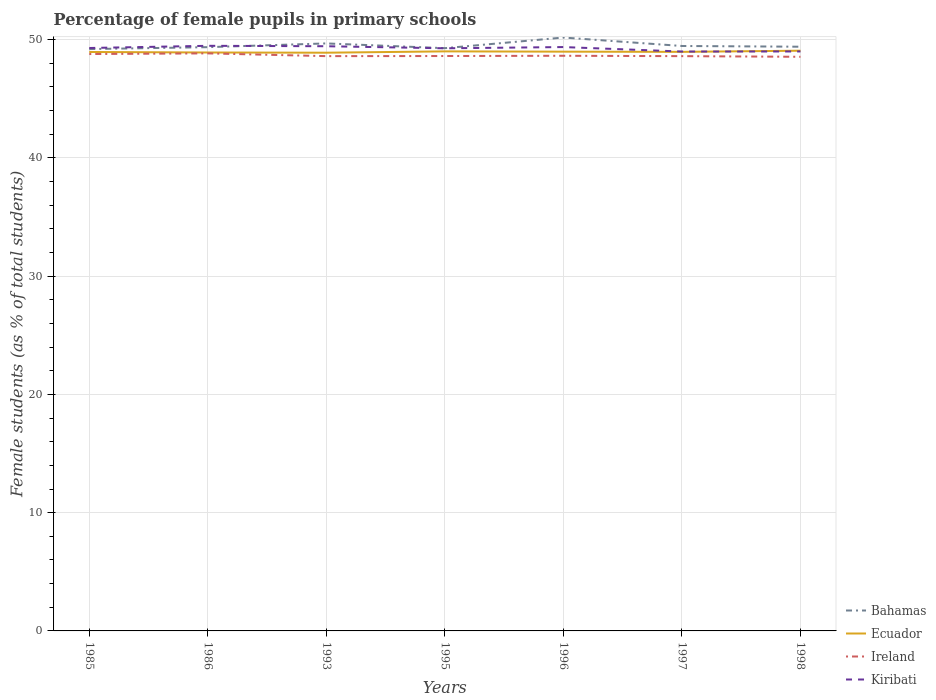Does the line corresponding to Ireland intersect with the line corresponding to Kiribati?
Ensure brevity in your answer.  No. Across all years, what is the maximum percentage of female pupils in primary schools in Ecuador?
Provide a succinct answer. 48.89. What is the total percentage of female pupils in primary schools in Bahamas in the graph?
Your answer should be compact. -0.08. What is the difference between the highest and the second highest percentage of female pupils in primary schools in Ireland?
Your answer should be compact. 0.29. What is the difference between the highest and the lowest percentage of female pupils in primary schools in Kiribati?
Your response must be concise. 5. Is the percentage of female pupils in primary schools in Ecuador strictly greater than the percentage of female pupils in primary schools in Bahamas over the years?
Give a very brief answer. Yes. What is the difference between two consecutive major ticks on the Y-axis?
Make the answer very short. 10. Does the graph contain any zero values?
Make the answer very short. No. Does the graph contain grids?
Keep it short and to the point. Yes. Where does the legend appear in the graph?
Ensure brevity in your answer.  Bottom right. How many legend labels are there?
Your answer should be very brief. 4. What is the title of the graph?
Keep it short and to the point. Percentage of female pupils in primary schools. What is the label or title of the Y-axis?
Keep it short and to the point. Female students (as % of total students). What is the Female students (as % of total students) of Bahamas in 1985?
Keep it short and to the point. 49.2. What is the Female students (as % of total students) of Ecuador in 1985?
Give a very brief answer. 48.96. What is the Female students (as % of total students) of Ireland in 1985?
Offer a very short reply. 48.78. What is the Female students (as % of total students) of Kiribati in 1985?
Offer a very short reply. 49.29. What is the Female students (as % of total students) in Bahamas in 1986?
Your answer should be compact. 49.36. What is the Female students (as % of total students) of Ecuador in 1986?
Ensure brevity in your answer.  48.91. What is the Female students (as % of total students) of Ireland in 1986?
Provide a succinct answer. 48.84. What is the Female students (as % of total students) of Kiribati in 1986?
Offer a terse response. 49.48. What is the Female students (as % of total students) of Bahamas in 1993?
Offer a very short reply. 49.68. What is the Female students (as % of total students) in Ecuador in 1993?
Your answer should be compact. 48.89. What is the Female students (as % of total students) in Ireland in 1993?
Offer a very short reply. 48.6. What is the Female students (as % of total students) in Kiribati in 1993?
Give a very brief answer. 49.44. What is the Female students (as % of total students) of Bahamas in 1995?
Your answer should be very brief. 49.28. What is the Female students (as % of total students) of Ecuador in 1995?
Give a very brief answer. 49.01. What is the Female students (as % of total students) in Ireland in 1995?
Ensure brevity in your answer.  48.61. What is the Female students (as % of total students) of Kiribati in 1995?
Keep it short and to the point. 49.27. What is the Female students (as % of total students) of Bahamas in 1996?
Your answer should be compact. 50.18. What is the Female students (as % of total students) of Ecuador in 1996?
Ensure brevity in your answer.  48.98. What is the Female students (as % of total students) in Ireland in 1996?
Keep it short and to the point. 48.64. What is the Female students (as % of total students) in Kiribati in 1996?
Your answer should be very brief. 49.37. What is the Female students (as % of total students) in Bahamas in 1997?
Make the answer very short. 49.46. What is the Female students (as % of total students) of Ecuador in 1997?
Provide a short and direct response. 48.97. What is the Female students (as % of total students) in Ireland in 1997?
Your response must be concise. 48.6. What is the Female students (as % of total students) in Kiribati in 1997?
Provide a short and direct response. 48.99. What is the Female students (as % of total students) in Bahamas in 1998?
Ensure brevity in your answer.  49.4. What is the Female students (as % of total students) in Ecuador in 1998?
Your answer should be compact. 49.06. What is the Female students (as % of total students) of Ireland in 1998?
Your answer should be very brief. 48.55. What is the Female students (as % of total students) in Kiribati in 1998?
Provide a short and direct response. 49. Across all years, what is the maximum Female students (as % of total students) in Bahamas?
Keep it short and to the point. 50.18. Across all years, what is the maximum Female students (as % of total students) of Ecuador?
Offer a terse response. 49.06. Across all years, what is the maximum Female students (as % of total students) in Ireland?
Keep it short and to the point. 48.84. Across all years, what is the maximum Female students (as % of total students) in Kiribati?
Offer a very short reply. 49.48. Across all years, what is the minimum Female students (as % of total students) of Bahamas?
Ensure brevity in your answer.  49.2. Across all years, what is the minimum Female students (as % of total students) in Ecuador?
Your response must be concise. 48.89. Across all years, what is the minimum Female students (as % of total students) of Ireland?
Offer a very short reply. 48.55. Across all years, what is the minimum Female students (as % of total students) in Kiribati?
Offer a very short reply. 48.99. What is the total Female students (as % of total students) of Bahamas in the graph?
Your answer should be compact. 346.56. What is the total Female students (as % of total students) of Ecuador in the graph?
Offer a very short reply. 342.78. What is the total Female students (as % of total students) in Ireland in the graph?
Make the answer very short. 340.63. What is the total Female students (as % of total students) of Kiribati in the graph?
Your response must be concise. 344.85. What is the difference between the Female students (as % of total students) of Bahamas in 1985 and that in 1986?
Your answer should be compact. -0.16. What is the difference between the Female students (as % of total students) of Ecuador in 1985 and that in 1986?
Your answer should be very brief. 0.04. What is the difference between the Female students (as % of total students) of Ireland in 1985 and that in 1986?
Provide a succinct answer. -0.06. What is the difference between the Female students (as % of total students) in Kiribati in 1985 and that in 1986?
Keep it short and to the point. -0.19. What is the difference between the Female students (as % of total students) of Bahamas in 1985 and that in 1993?
Offer a terse response. -0.48. What is the difference between the Female students (as % of total students) in Ecuador in 1985 and that in 1993?
Your response must be concise. 0.06. What is the difference between the Female students (as % of total students) in Ireland in 1985 and that in 1993?
Offer a terse response. 0.18. What is the difference between the Female students (as % of total students) of Kiribati in 1985 and that in 1993?
Your answer should be compact. -0.15. What is the difference between the Female students (as % of total students) in Bahamas in 1985 and that in 1995?
Your response must be concise. -0.08. What is the difference between the Female students (as % of total students) of Ecuador in 1985 and that in 1995?
Offer a terse response. -0.05. What is the difference between the Female students (as % of total students) in Ireland in 1985 and that in 1995?
Offer a terse response. 0.17. What is the difference between the Female students (as % of total students) of Kiribati in 1985 and that in 1995?
Your answer should be compact. 0.02. What is the difference between the Female students (as % of total students) of Bahamas in 1985 and that in 1996?
Keep it short and to the point. -0.98. What is the difference between the Female students (as % of total students) of Ecuador in 1985 and that in 1996?
Provide a short and direct response. -0.03. What is the difference between the Female students (as % of total students) in Ireland in 1985 and that in 1996?
Give a very brief answer. 0.15. What is the difference between the Female students (as % of total students) of Kiribati in 1985 and that in 1996?
Make the answer very short. -0.08. What is the difference between the Female students (as % of total students) in Bahamas in 1985 and that in 1997?
Your response must be concise. -0.26. What is the difference between the Female students (as % of total students) of Ecuador in 1985 and that in 1997?
Provide a succinct answer. -0.01. What is the difference between the Female students (as % of total students) of Ireland in 1985 and that in 1997?
Offer a very short reply. 0.18. What is the difference between the Female students (as % of total students) of Kiribati in 1985 and that in 1997?
Keep it short and to the point. 0.3. What is the difference between the Female students (as % of total students) of Bahamas in 1985 and that in 1998?
Offer a very short reply. -0.2. What is the difference between the Female students (as % of total students) in Ecuador in 1985 and that in 1998?
Your answer should be very brief. -0.11. What is the difference between the Female students (as % of total students) in Ireland in 1985 and that in 1998?
Your response must be concise. 0.23. What is the difference between the Female students (as % of total students) in Kiribati in 1985 and that in 1998?
Provide a succinct answer. 0.29. What is the difference between the Female students (as % of total students) of Bahamas in 1986 and that in 1993?
Your response must be concise. -0.32. What is the difference between the Female students (as % of total students) of Ecuador in 1986 and that in 1993?
Your response must be concise. 0.02. What is the difference between the Female students (as % of total students) in Ireland in 1986 and that in 1993?
Make the answer very short. 0.23. What is the difference between the Female students (as % of total students) in Kiribati in 1986 and that in 1993?
Offer a terse response. 0.04. What is the difference between the Female students (as % of total students) of Bahamas in 1986 and that in 1995?
Make the answer very short. 0.09. What is the difference between the Female students (as % of total students) of Ecuador in 1986 and that in 1995?
Your answer should be compact. -0.1. What is the difference between the Female students (as % of total students) in Ireland in 1986 and that in 1995?
Provide a succinct answer. 0.22. What is the difference between the Female students (as % of total students) in Kiribati in 1986 and that in 1995?
Give a very brief answer. 0.21. What is the difference between the Female students (as % of total students) of Bahamas in 1986 and that in 1996?
Your answer should be compact. -0.81. What is the difference between the Female students (as % of total students) in Ecuador in 1986 and that in 1996?
Your answer should be compact. -0.07. What is the difference between the Female students (as % of total students) of Ireland in 1986 and that in 1996?
Provide a succinct answer. 0.2. What is the difference between the Female students (as % of total students) of Kiribati in 1986 and that in 1996?
Offer a very short reply. 0.11. What is the difference between the Female students (as % of total students) in Bahamas in 1986 and that in 1997?
Offer a terse response. -0.1. What is the difference between the Female students (as % of total students) of Ecuador in 1986 and that in 1997?
Keep it short and to the point. -0.05. What is the difference between the Female students (as % of total students) of Ireland in 1986 and that in 1997?
Offer a very short reply. 0.23. What is the difference between the Female students (as % of total students) of Kiribati in 1986 and that in 1997?
Provide a succinct answer. 0.48. What is the difference between the Female students (as % of total students) in Bahamas in 1986 and that in 1998?
Make the answer very short. -0.04. What is the difference between the Female students (as % of total students) in Ecuador in 1986 and that in 1998?
Your response must be concise. -0.15. What is the difference between the Female students (as % of total students) in Ireland in 1986 and that in 1998?
Provide a succinct answer. 0.29. What is the difference between the Female students (as % of total students) in Kiribati in 1986 and that in 1998?
Provide a short and direct response. 0.48. What is the difference between the Female students (as % of total students) in Bahamas in 1993 and that in 1995?
Make the answer very short. 0.4. What is the difference between the Female students (as % of total students) of Ecuador in 1993 and that in 1995?
Give a very brief answer. -0.11. What is the difference between the Female students (as % of total students) of Ireland in 1993 and that in 1995?
Your response must be concise. -0.01. What is the difference between the Female students (as % of total students) in Kiribati in 1993 and that in 1995?
Offer a very short reply. 0.17. What is the difference between the Female students (as % of total students) in Bahamas in 1993 and that in 1996?
Provide a succinct answer. -0.5. What is the difference between the Female students (as % of total students) in Ecuador in 1993 and that in 1996?
Provide a short and direct response. -0.09. What is the difference between the Female students (as % of total students) of Ireland in 1993 and that in 1996?
Your answer should be compact. -0.03. What is the difference between the Female students (as % of total students) of Kiribati in 1993 and that in 1996?
Offer a terse response. 0.07. What is the difference between the Female students (as % of total students) of Bahamas in 1993 and that in 1997?
Keep it short and to the point. 0.22. What is the difference between the Female students (as % of total students) of Ecuador in 1993 and that in 1997?
Provide a succinct answer. -0.07. What is the difference between the Female students (as % of total students) in Kiribati in 1993 and that in 1997?
Keep it short and to the point. 0.45. What is the difference between the Female students (as % of total students) in Bahamas in 1993 and that in 1998?
Keep it short and to the point. 0.28. What is the difference between the Female students (as % of total students) of Ecuador in 1993 and that in 1998?
Offer a terse response. -0.17. What is the difference between the Female students (as % of total students) of Ireland in 1993 and that in 1998?
Keep it short and to the point. 0.06. What is the difference between the Female students (as % of total students) of Kiribati in 1993 and that in 1998?
Give a very brief answer. 0.44. What is the difference between the Female students (as % of total students) in Bahamas in 1995 and that in 1996?
Give a very brief answer. -0.9. What is the difference between the Female students (as % of total students) in Ecuador in 1995 and that in 1996?
Provide a short and direct response. 0.02. What is the difference between the Female students (as % of total students) in Ireland in 1995 and that in 1996?
Your response must be concise. -0.02. What is the difference between the Female students (as % of total students) in Kiribati in 1995 and that in 1996?
Your answer should be very brief. -0.1. What is the difference between the Female students (as % of total students) in Bahamas in 1995 and that in 1997?
Offer a terse response. -0.18. What is the difference between the Female students (as % of total students) in Ecuador in 1995 and that in 1997?
Give a very brief answer. 0.04. What is the difference between the Female students (as % of total students) in Ireland in 1995 and that in 1997?
Offer a very short reply. 0.01. What is the difference between the Female students (as % of total students) of Kiribati in 1995 and that in 1997?
Keep it short and to the point. 0.27. What is the difference between the Female students (as % of total students) in Bahamas in 1995 and that in 1998?
Provide a succinct answer. -0.12. What is the difference between the Female students (as % of total students) of Ecuador in 1995 and that in 1998?
Make the answer very short. -0.06. What is the difference between the Female students (as % of total students) of Ireland in 1995 and that in 1998?
Give a very brief answer. 0.07. What is the difference between the Female students (as % of total students) of Kiribati in 1995 and that in 1998?
Keep it short and to the point. 0.27. What is the difference between the Female students (as % of total students) of Bahamas in 1996 and that in 1997?
Keep it short and to the point. 0.71. What is the difference between the Female students (as % of total students) in Ecuador in 1996 and that in 1997?
Keep it short and to the point. 0.02. What is the difference between the Female students (as % of total students) of Ireland in 1996 and that in 1997?
Keep it short and to the point. 0.03. What is the difference between the Female students (as % of total students) in Kiribati in 1996 and that in 1997?
Your answer should be very brief. 0.38. What is the difference between the Female students (as % of total students) of Bahamas in 1996 and that in 1998?
Your answer should be compact. 0.78. What is the difference between the Female students (as % of total students) of Ecuador in 1996 and that in 1998?
Offer a very short reply. -0.08. What is the difference between the Female students (as % of total students) of Ireland in 1996 and that in 1998?
Offer a terse response. 0.09. What is the difference between the Female students (as % of total students) in Kiribati in 1996 and that in 1998?
Provide a short and direct response. 0.37. What is the difference between the Female students (as % of total students) in Bahamas in 1997 and that in 1998?
Make the answer very short. 0.06. What is the difference between the Female students (as % of total students) of Ecuador in 1997 and that in 1998?
Give a very brief answer. -0.1. What is the difference between the Female students (as % of total students) in Ireland in 1997 and that in 1998?
Keep it short and to the point. 0.05. What is the difference between the Female students (as % of total students) of Kiribati in 1997 and that in 1998?
Keep it short and to the point. -0.01. What is the difference between the Female students (as % of total students) in Bahamas in 1985 and the Female students (as % of total students) in Ecuador in 1986?
Keep it short and to the point. 0.29. What is the difference between the Female students (as % of total students) in Bahamas in 1985 and the Female students (as % of total students) in Ireland in 1986?
Ensure brevity in your answer.  0.36. What is the difference between the Female students (as % of total students) in Bahamas in 1985 and the Female students (as % of total students) in Kiribati in 1986?
Your answer should be compact. -0.28. What is the difference between the Female students (as % of total students) of Ecuador in 1985 and the Female students (as % of total students) of Ireland in 1986?
Your response must be concise. 0.12. What is the difference between the Female students (as % of total students) in Ecuador in 1985 and the Female students (as % of total students) in Kiribati in 1986?
Keep it short and to the point. -0.52. What is the difference between the Female students (as % of total students) in Ireland in 1985 and the Female students (as % of total students) in Kiribati in 1986?
Your answer should be compact. -0.7. What is the difference between the Female students (as % of total students) of Bahamas in 1985 and the Female students (as % of total students) of Ecuador in 1993?
Your response must be concise. 0.31. What is the difference between the Female students (as % of total students) in Bahamas in 1985 and the Female students (as % of total students) in Ireland in 1993?
Your answer should be compact. 0.6. What is the difference between the Female students (as % of total students) of Bahamas in 1985 and the Female students (as % of total students) of Kiribati in 1993?
Make the answer very short. -0.24. What is the difference between the Female students (as % of total students) of Ecuador in 1985 and the Female students (as % of total students) of Ireland in 1993?
Give a very brief answer. 0.35. What is the difference between the Female students (as % of total students) of Ecuador in 1985 and the Female students (as % of total students) of Kiribati in 1993?
Keep it short and to the point. -0.49. What is the difference between the Female students (as % of total students) of Ireland in 1985 and the Female students (as % of total students) of Kiribati in 1993?
Keep it short and to the point. -0.66. What is the difference between the Female students (as % of total students) of Bahamas in 1985 and the Female students (as % of total students) of Ecuador in 1995?
Offer a very short reply. 0.19. What is the difference between the Female students (as % of total students) in Bahamas in 1985 and the Female students (as % of total students) in Ireland in 1995?
Offer a very short reply. 0.59. What is the difference between the Female students (as % of total students) of Bahamas in 1985 and the Female students (as % of total students) of Kiribati in 1995?
Your answer should be compact. -0.07. What is the difference between the Female students (as % of total students) in Ecuador in 1985 and the Female students (as % of total students) in Ireland in 1995?
Keep it short and to the point. 0.34. What is the difference between the Female students (as % of total students) of Ecuador in 1985 and the Female students (as % of total students) of Kiribati in 1995?
Ensure brevity in your answer.  -0.31. What is the difference between the Female students (as % of total students) in Ireland in 1985 and the Female students (as % of total students) in Kiribati in 1995?
Offer a terse response. -0.49. What is the difference between the Female students (as % of total students) in Bahamas in 1985 and the Female students (as % of total students) in Ecuador in 1996?
Your answer should be very brief. 0.22. What is the difference between the Female students (as % of total students) of Bahamas in 1985 and the Female students (as % of total students) of Ireland in 1996?
Offer a terse response. 0.57. What is the difference between the Female students (as % of total students) of Bahamas in 1985 and the Female students (as % of total students) of Kiribati in 1996?
Make the answer very short. -0.17. What is the difference between the Female students (as % of total students) of Ecuador in 1985 and the Female students (as % of total students) of Ireland in 1996?
Ensure brevity in your answer.  0.32. What is the difference between the Female students (as % of total students) in Ecuador in 1985 and the Female students (as % of total students) in Kiribati in 1996?
Make the answer very short. -0.42. What is the difference between the Female students (as % of total students) of Ireland in 1985 and the Female students (as % of total students) of Kiribati in 1996?
Give a very brief answer. -0.59. What is the difference between the Female students (as % of total students) of Bahamas in 1985 and the Female students (as % of total students) of Ecuador in 1997?
Offer a very short reply. 0.23. What is the difference between the Female students (as % of total students) of Bahamas in 1985 and the Female students (as % of total students) of Ireland in 1997?
Your response must be concise. 0.6. What is the difference between the Female students (as % of total students) of Bahamas in 1985 and the Female students (as % of total students) of Kiribati in 1997?
Keep it short and to the point. 0.21. What is the difference between the Female students (as % of total students) of Ecuador in 1985 and the Female students (as % of total students) of Ireland in 1997?
Your response must be concise. 0.35. What is the difference between the Female students (as % of total students) of Ecuador in 1985 and the Female students (as % of total students) of Kiribati in 1997?
Offer a terse response. -0.04. What is the difference between the Female students (as % of total students) in Ireland in 1985 and the Female students (as % of total students) in Kiribati in 1997?
Give a very brief answer. -0.21. What is the difference between the Female students (as % of total students) in Bahamas in 1985 and the Female students (as % of total students) in Ecuador in 1998?
Make the answer very short. 0.14. What is the difference between the Female students (as % of total students) of Bahamas in 1985 and the Female students (as % of total students) of Ireland in 1998?
Ensure brevity in your answer.  0.65. What is the difference between the Female students (as % of total students) in Bahamas in 1985 and the Female students (as % of total students) in Kiribati in 1998?
Keep it short and to the point. 0.2. What is the difference between the Female students (as % of total students) in Ecuador in 1985 and the Female students (as % of total students) in Ireland in 1998?
Your answer should be compact. 0.41. What is the difference between the Female students (as % of total students) in Ecuador in 1985 and the Female students (as % of total students) in Kiribati in 1998?
Your answer should be very brief. -0.04. What is the difference between the Female students (as % of total students) in Ireland in 1985 and the Female students (as % of total students) in Kiribati in 1998?
Offer a very short reply. -0.22. What is the difference between the Female students (as % of total students) in Bahamas in 1986 and the Female students (as % of total students) in Ecuador in 1993?
Give a very brief answer. 0.47. What is the difference between the Female students (as % of total students) of Bahamas in 1986 and the Female students (as % of total students) of Ireland in 1993?
Offer a very short reply. 0.76. What is the difference between the Female students (as % of total students) of Bahamas in 1986 and the Female students (as % of total students) of Kiribati in 1993?
Make the answer very short. -0.08. What is the difference between the Female students (as % of total students) in Ecuador in 1986 and the Female students (as % of total students) in Ireland in 1993?
Offer a terse response. 0.31. What is the difference between the Female students (as % of total students) of Ecuador in 1986 and the Female students (as % of total students) of Kiribati in 1993?
Provide a short and direct response. -0.53. What is the difference between the Female students (as % of total students) of Ireland in 1986 and the Female students (as % of total students) of Kiribati in 1993?
Keep it short and to the point. -0.6. What is the difference between the Female students (as % of total students) in Bahamas in 1986 and the Female students (as % of total students) in Ecuador in 1995?
Provide a short and direct response. 0.36. What is the difference between the Female students (as % of total students) of Bahamas in 1986 and the Female students (as % of total students) of Ireland in 1995?
Your answer should be compact. 0.75. What is the difference between the Female students (as % of total students) of Bahamas in 1986 and the Female students (as % of total students) of Kiribati in 1995?
Your response must be concise. 0.1. What is the difference between the Female students (as % of total students) in Ecuador in 1986 and the Female students (as % of total students) in Ireland in 1995?
Offer a terse response. 0.3. What is the difference between the Female students (as % of total students) of Ecuador in 1986 and the Female students (as % of total students) of Kiribati in 1995?
Your answer should be very brief. -0.36. What is the difference between the Female students (as % of total students) in Ireland in 1986 and the Female students (as % of total students) in Kiribati in 1995?
Ensure brevity in your answer.  -0.43. What is the difference between the Female students (as % of total students) of Bahamas in 1986 and the Female students (as % of total students) of Ecuador in 1996?
Keep it short and to the point. 0.38. What is the difference between the Female students (as % of total students) of Bahamas in 1986 and the Female students (as % of total students) of Ireland in 1996?
Your answer should be compact. 0.73. What is the difference between the Female students (as % of total students) of Bahamas in 1986 and the Female students (as % of total students) of Kiribati in 1996?
Give a very brief answer. -0.01. What is the difference between the Female students (as % of total students) in Ecuador in 1986 and the Female students (as % of total students) in Ireland in 1996?
Keep it short and to the point. 0.28. What is the difference between the Female students (as % of total students) of Ecuador in 1986 and the Female students (as % of total students) of Kiribati in 1996?
Provide a succinct answer. -0.46. What is the difference between the Female students (as % of total students) of Ireland in 1986 and the Female students (as % of total students) of Kiribati in 1996?
Keep it short and to the point. -0.53. What is the difference between the Female students (as % of total students) of Bahamas in 1986 and the Female students (as % of total students) of Ecuador in 1997?
Your answer should be very brief. 0.4. What is the difference between the Female students (as % of total students) in Bahamas in 1986 and the Female students (as % of total students) in Ireland in 1997?
Your answer should be very brief. 0.76. What is the difference between the Female students (as % of total students) in Bahamas in 1986 and the Female students (as % of total students) in Kiribati in 1997?
Ensure brevity in your answer.  0.37. What is the difference between the Female students (as % of total students) in Ecuador in 1986 and the Female students (as % of total students) in Ireland in 1997?
Offer a very short reply. 0.31. What is the difference between the Female students (as % of total students) in Ecuador in 1986 and the Female students (as % of total students) in Kiribati in 1997?
Ensure brevity in your answer.  -0.08. What is the difference between the Female students (as % of total students) of Ireland in 1986 and the Female students (as % of total students) of Kiribati in 1997?
Give a very brief answer. -0.16. What is the difference between the Female students (as % of total students) in Bahamas in 1986 and the Female students (as % of total students) in Ireland in 1998?
Your answer should be very brief. 0.81. What is the difference between the Female students (as % of total students) of Bahamas in 1986 and the Female students (as % of total students) of Kiribati in 1998?
Provide a short and direct response. 0.36. What is the difference between the Female students (as % of total students) of Ecuador in 1986 and the Female students (as % of total students) of Ireland in 1998?
Ensure brevity in your answer.  0.36. What is the difference between the Female students (as % of total students) of Ecuador in 1986 and the Female students (as % of total students) of Kiribati in 1998?
Your response must be concise. -0.09. What is the difference between the Female students (as % of total students) in Ireland in 1986 and the Female students (as % of total students) in Kiribati in 1998?
Offer a very short reply. -0.16. What is the difference between the Female students (as % of total students) in Bahamas in 1993 and the Female students (as % of total students) in Ecuador in 1995?
Make the answer very short. 0.67. What is the difference between the Female students (as % of total students) of Bahamas in 1993 and the Female students (as % of total students) of Ireland in 1995?
Your answer should be compact. 1.07. What is the difference between the Female students (as % of total students) in Bahamas in 1993 and the Female students (as % of total students) in Kiribati in 1995?
Ensure brevity in your answer.  0.41. What is the difference between the Female students (as % of total students) of Ecuador in 1993 and the Female students (as % of total students) of Ireland in 1995?
Offer a terse response. 0.28. What is the difference between the Female students (as % of total students) of Ecuador in 1993 and the Female students (as % of total students) of Kiribati in 1995?
Make the answer very short. -0.37. What is the difference between the Female students (as % of total students) in Ireland in 1993 and the Female students (as % of total students) in Kiribati in 1995?
Offer a terse response. -0.66. What is the difference between the Female students (as % of total students) of Bahamas in 1993 and the Female students (as % of total students) of Ecuador in 1996?
Your answer should be compact. 0.7. What is the difference between the Female students (as % of total students) in Bahamas in 1993 and the Female students (as % of total students) in Ireland in 1996?
Keep it short and to the point. 1.04. What is the difference between the Female students (as % of total students) in Bahamas in 1993 and the Female students (as % of total students) in Kiribati in 1996?
Provide a succinct answer. 0.31. What is the difference between the Female students (as % of total students) in Ecuador in 1993 and the Female students (as % of total students) in Ireland in 1996?
Keep it short and to the point. 0.26. What is the difference between the Female students (as % of total students) in Ecuador in 1993 and the Female students (as % of total students) in Kiribati in 1996?
Provide a succinct answer. -0.48. What is the difference between the Female students (as % of total students) in Ireland in 1993 and the Female students (as % of total students) in Kiribati in 1996?
Your answer should be compact. -0.77. What is the difference between the Female students (as % of total students) of Bahamas in 1993 and the Female students (as % of total students) of Ecuador in 1997?
Your answer should be compact. 0.71. What is the difference between the Female students (as % of total students) in Bahamas in 1993 and the Female students (as % of total students) in Ireland in 1997?
Offer a terse response. 1.08. What is the difference between the Female students (as % of total students) of Bahamas in 1993 and the Female students (as % of total students) of Kiribati in 1997?
Make the answer very short. 0.69. What is the difference between the Female students (as % of total students) of Ecuador in 1993 and the Female students (as % of total students) of Ireland in 1997?
Provide a succinct answer. 0.29. What is the difference between the Female students (as % of total students) of Ecuador in 1993 and the Female students (as % of total students) of Kiribati in 1997?
Provide a succinct answer. -0.1. What is the difference between the Female students (as % of total students) of Ireland in 1993 and the Female students (as % of total students) of Kiribati in 1997?
Your answer should be compact. -0.39. What is the difference between the Female students (as % of total students) of Bahamas in 1993 and the Female students (as % of total students) of Ecuador in 1998?
Make the answer very short. 0.62. What is the difference between the Female students (as % of total students) of Bahamas in 1993 and the Female students (as % of total students) of Ireland in 1998?
Provide a short and direct response. 1.13. What is the difference between the Female students (as % of total students) in Bahamas in 1993 and the Female students (as % of total students) in Kiribati in 1998?
Make the answer very short. 0.68. What is the difference between the Female students (as % of total students) in Ecuador in 1993 and the Female students (as % of total students) in Ireland in 1998?
Your response must be concise. 0.34. What is the difference between the Female students (as % of total students) in Ecuador in 1993 and the Female students (as % of total students) in Kiribati in 1998?
Give a very brief answer. -0.11. What is the difference between the Female students (as % of total students) of Ireland in 1993 and the Female students (as % of total students) of Kiribati in 1998?
Give a very brief answer. -0.4. What is the difference between the Female students (as % of total students) of Bahamas in 1995 and the Female students (as % of total students) of Ecuador in 1996?
Make the answer very short. 0.29. What is the difference between the Female students (as % of total students) of Bahamas in 1995 and the Female students (as % of total students) of Ireland in 1996?
Provide a short and direct response. 0.64. What is the difference between the Female students (as % of total students) in Bahamas in 1995 and the Female students (as % of total students) in Kiribati in 1996?
Your response must be concise. -0.09. What is the difference between the Female students (as % of total students) in Ecuador in 1995 and the Female students (as % of total students) in Ireland in 1996?
Make the answer very short. 0.37. What is the difference between the Female students (as % of total students) in Ecuador in 1995 and the Female students (as % of total students) in Kiribati in 1996?
Your answer should be very brief. -0.36. What is the difference between the Female students (as % of total students) of Ireland in 1995 and the Female students (as % of total students) of Kiribati in 1996?
Offer a terse response. -0.76. What is the difference between the Female students (as % of total students) of Bahamas in 1995 and the Female students (as % of total students) of Ecuador in 1997?
Your answer should be compact. 0.31. What is the difference between the Female students (as % of total students) in Bahamas in 1995 and the Female students (as % of total students) in Ireland in 1997?
Keep it short and to the point. 0.67. What is the difference between the Female students (as % of total students) of Bahamas in 1995 and the Female students (as % of total students) of Kiribati in 1997?
Give a very brief answer. 0.28. What is the difference between the Female students (as % of total students) in Ecuador in 1995 and the Female students (as % of total students) in Ireland in 1997?
Provide a succinct answer. 0.4. What is the difference between the Female students (as % of total students) in Ecuador in 1995 and the Female students (as % of total students) in Kiribati in 1997?
Keep it short and to the point. 0.01. What is the difference between the Female students (as % of total students) in Ireland in 1995 and the Female students (as % of total students) in Kiribati in 1997?
Ensure brevity in your answer.  -0.38. What is the difference between the Female students (as % of total students) in Bahamas in 1995 and the Female students (as % of total students) in Ecuador in 1998?
Your response must be concise. 0.21. What is the difference between the Female students (as % of total students) in Bahamas in 1995 and the Female students (as % of total students) in Ireland in 1998?
Offer a very short reply. 0.73. What is the difference between the Female students (as % of total students) of Bahamas in 1995 and the Female students (as % of total students) of Kiribati in 1998?
Your answer should be compact. 0.28. What is the difference between the Female students (as % of total students) in Ecuador in 1995 and the Female students (as % of total students) in Ireland in 1998?
Keep it short and to the point. 0.46. What is the difference between the Female students (as % of total students) of Ecuador in 1995 and the Female students (as % of total students) of Kiribati in 1998?
Your response must be concise. 0.01. What is the difference between the Female students (as % of total students) of Ireland in 1995 and the Female students (as % of total students) of Kiribati in 1998?
Your answer should be compact. -0.39. What is the difference between the Female students (as % of total students) in Bahamas in 1996 and the Female students (as % of total students) in Ecuador in 1997?
Keep it short and to the point. 1.21. What is the difference between the Female students (as % of total students) in Bahamas in 1996 and the Female students (as % of total students) in Ireland in 1997?
Make the answer very short. 1.57. What is the difference between the Female students (as % of total students) of Bahamas in 1996 and the Female students (as % of total students) of Kiribati in 1997?
Give a very brief answer. 1.18. What is the difference between the Female students (as % of total students) in Ecuador in 1996 and the Female students (as % of total students) in Ireland in 1997?
Offer a terse response. 0.38. What is the difference between the Female students (as % of total students) in Ecuador in 1996 and the Female students (as % of total students) in Kiribati in 1997?
Your answer should be compact. -0.01. What is the difference between the Female students (as % of total students) of Ireland in 1996 and the Female students (as % of total students) of Kiribati in 1997?
Provide a succinct answer. -0.36. What is the difference between the Female students (as % of total students) of Bahamas in 1996 and the Female students (as % of total students) of Ecuador in 1998?
Provide a short and direct response. 1.11. What is the difference between the Female students (as % of total students) of Bahamas in 1996 and the Female students (as % of total students) of Ireland in 1998?
Keep it short and to the point. 1.63. What is the difference between the Female students (as % of total students) in Bahamas in 1996 and the Female students (as % of total students) in Kiribati in 1998?
Offer a terse response. 1.18. What is the difference between the Female students (as % of total students) of Ecuador in 1996 and the Female students (as % of total students) of Ireland in 1998?
Offer a terse response. 0.43. What is the difference between the Female students (as % of total students) in Ecuador in 1996 and the Female students (as % of total students) in Kiribati in 1998?
Your answer should be compact. -0.02. What is the difference between the Female students (as % of total students) of Ireland in 1996 and the Female students (as % of total students) of Kiribati in 1998?
Offer a very short reply. -0.36. What is the difference between the Female students (as % of total students) of Bahamas in 1997 and the Female students (as % of total students) of Ecuador in 1998?
Your response must be concise. 0.4. What is the difference between the Female students (as % of total students) of Bahamas in 1997 and the Female students (as % of total students) of Ireland in 1998?
Your response must be concise. 0.91. What is the difference between the Female students (as % of total students) of Bahamas in 1997 and the Female students (as % of total students) of Kiribati in 1998?
Provide a short and direct response. 0.46. What is the difference between the Female students (as % of total students) of Ecuador in 1997 and the Female students (as % of total students) of Ireland in 1998?
Your answer should be compact. 0.42. What is the difference between the Female students (as % of total students) in Ecuador in 1997 and the Female students (as % of total students) in Kiribati in 1998?
Provide a short and direct response. -0.03. What is the difference between the Female students (as % of total students) of Ireland in 1997 and the Female students (as % of total students) of Kiribati in 1998?
Provide a succinct answer. -0.4. What is the average Female students (as % of total students) of Bahamas per year?
Offer a very short reply. 49.51. What is the average Female students (as % of total students) in Ecuador per year?
Offer a very short reply. 48.97. What is the average Female students (as % of total students) in Ireland per year?
Your answer should be compact. 48.66. What is the average Female students (as % of total students) of Kiribati per year?
Keep it short and to the point. 49.26. In the year 1985, what is the difference between the Female students (as % of total students) in Bahamas and Female students (as % of total students) in Ecuador?
Offer a very short reply. 0.25. In the year 1985, what is the difference between the Female students (as % of total students) of Bahamas and Female students (as % of total students) of Ireland?
Your answer should be compact. 0.42. In the year 1985, what is the difference between the Female students (as % of total students) in Bahamas and Female students (as % of total students) in Kiribati?
Offer a very short reply. -0.09. In the year 1985, what is the difference between the Female students (as % of total students) in Ecuador and Female students (as % of total students) in Ireland?
Provide a short and direct response. 0.17. In the year 1985, what is the difference between the Female students (as % of total students) of Ecuador and Female students (as % of total students) of Kiribati?
Your response must be concise. -0.34. In the year 1985, what is the difference between the Female students (as % of total students) of Ireland and Female students (as % of total students) of Kiribati?
Provide a short and direct response. -0.51. In the year 1986, what is the difference between the Female students (as % of total students) in Bahamas and Female students (as % of total students) in Ecuador?
Provide a succinct answer. 0.45. In the year 1986, what is the difference between the Female students (as % of total students) of Bahamas and Female students (as % of total students) of Ireland?
Make the answer very short. 0.53. In the year 1986, what is the difference between the Female students (as % of total students) of Bahamas and Female students (as % of total students) of Kiribati?
Offer a terse response. -0.11. In the year 1986, what is the difference between the Female students (as % of total students) in Ecuador and Female students (as % of total students) in Ireland?
Offer a very short reply. 0.07. In the year 1986, what is the difference between the Female students (as % of total students) of Ecuador and Female students (as % of total students) of Kiribati?
Your answer should be compact. -0.57. In the year 1986, what is the difference between the Female students (as % of total students) of Ireland and Female students (as % of total students) of Kiribati?
Make the answer very short. -0.64. In the year 1993, what is the difference between the Female students (as % of total students) of Bahamas and Female students (as % of total students) of Ecuador?
Provide a succinct answer. 0.79. In the year 1993, what is the difference between the Female students (as % of total students) in Bahamas and Female students (as % of total students) in Ireland?
Your response must be concise. 1.08. In the year 1993, what is the difference between the Female students (as % of total students) of Bahamas and Female students (as % of total students) of Kiribati?
Give a very brief answer. 0.24. In the year 1993, what is the difference between the Female students (as % of total students) in Ecuador and Female students (as % of total students) in Ireland?
Your response must be concise. 0.29. In the year 1993, what is the difference between the Female students (as % of total students) of Ecuador and Female students (as % of total students) of Kiribati?
Your answer should be very brief. -0.55. In the year 1993, what is the difference between the Female students (as % of total students) in Ireland and Female students (as % of total students) in Kiribati?
Your answer should be compact. -0.84. In the year 1995, what is the difference between the Female students (as % of total students) in Bahamas and Female students (as % of total students) in Ecuador?
Make the answer very short. 0.27. In the year 1995, what is the difference between the Female students (as % of total students) in Bahamas and Female students (as % of total students) in Ireland?
Your answer should be compact. 0.66. In the year 1995, what is the difference between the Female students (as % of total students) in Bahamas and Female students (as % of total students) in Kiribati?
Make the answer very short. 0.01. In the year 1995, what is the difference between the Female students (as % of total students) in Ecuador and Female students (as % of total students) in Ireland?
Your answer should be very brief. 0.39. In the year 1995, what is the difference between the Female students (as % of total students) in Ecuador and Female students (as % of total students) in Kiribati?
Ensure brevity in your answer.  -0.26. In the year 1995, what is the difference between the Female students (as % of total students) in Ireland and Female students (as % of total students) in Kiribati?
Offer a terse response. -0.65. In the year 1996, what is the difference between the Female students (as % of total students) of Bahamas and Female students (as % of total students) of Ecuador?
Offer a very short reply. 1.19. In the year 1996, what is the difference between the Female students (as % of total students) in Bahamas and Female students (as % of total students) in Ireland?
Your response must be concise. 1.54. In the year 1996, what is the difference between the Female students (as % of total students) in Bahamas and Female students (as % of total students) in Kiribati?
Ensure brevity in your answer.  0.81. In the year 1996, what is the difference between the Female students (as % of total students) in Ecuador and Female students (as % of total students) in Ireland?
Provide a succinct answer. 0.35. In the year 1996, what is the difference between the Female students (as % of total students) of Ecuador and Female students (as % of total students) of Kiribati?
Provide a short and direct response. -0.39. In the year 1996, what is the difference between the Female students (as % of total students) of Ireland and Female students (as % of total students) of Kiribati?
Offer a very short reply. -0.74. In the year 1997, what is the difference between the Female students (as % of total students) of Bahamas and Female students (as % of total students) of Ecuador?
Ensure brevity in your answer.  0.5. In the year 1997, what is the difference between the Female students (as % of total students) in Bahamas and Female students (as % of total students) in Ireland?
Keep it short and to the point. 0.86. In the year 1997, what is the difference between the Female students (as % of total students) of Bahamas and Female students (as % of total students) of Kiribati?
Give a very brief answer. 0.47. In the year 1997, what is the difference between the Female students (as % of total students) of Ecuador and Female students (as % of total students) of Ireland?
Your answer should be very brief. 0.36. In the year 1997, what is the difference between the Female students (as % of total students) of Ecuador and Female students (as % of total students) of Kiribati?
Your response must be concise. -0.03. In the year 1997, what is the difference between the Female students (as % of total students) in Ireland and Female students (as % of total students) in Kiribati?
Your response must be concise. -0.39. In the year 1998, what is the difference between the Female students (as % of total students) in Bahamas and Female students (as % of total students) in Ecuador?
Your answer should be compact. 0.34. In the year 1998, what is the difference between the Female students (as % of total students) in Bahamas and Female students (as % of total students) in Ireland?
Provide a succinct answer. 0.85. In the year 1998, what is the difference between the Female students (as % of total students) in Bahamas and Female students (as % of total students) in Kiribati?
Offer a terse response. 0.4. In the year 1998, what is the difference between the Female students (as % of total students) in Ecuador and Female students (as % of total students) in Ireland?
Provide a succinct answer. 0.51. In the year 1998, what is the difference between the Female students (as % of total students) of Ecuador and Female students (as % of total students) of Kiribati?
Provide a short and direct response. 0.06. In the year 1998, what is the difference between the Female students (as % of total students) of Ireland and Female students (as % of total students) of Kiribati?
Your answer should be very brief. -0.45. What is the ratio of the Female students (as % of total students) in Bahamas in 1985 to that in 1986?
Offer a very short reply. 1. What is the ratio of the Female students (as % of total students) of Ecuador in 1985 to that in 1986?
Offer a terse response. 1. What is the ratio of the Female students (as % of total students) in Ireland in 1985 to that in 1986?
Your answer should be very brief. 1. What is the ratio of the Female students (as % of total students) of Kiribati in 1985 to that in 1986?
Give a very brief answer. 1. What is the ratio of the Female students (as % of total students) in Bahamas in 1985 to that in 1993?
Offer a terse response. 0.99. What is the ratio of the Female students (as % of total students) in Ecuador in 1985 to that in 1993?
Provide a short and direct response. 1. What is the ratio of the Female students (as % of total students) in Ecuador in 1985 to that in 1995?
Provide a succinct answer. 1. What is the ratio of the Female students (as % of total students) of Ireland in 1985 to that in 1995?
Keep it short and to the point. 1. What is the ratio of the Female students (as % of total students) of Bahamas in 1985 to that in 1996?
Make the answer very short. 0.98. What is the ratio of the Female students (as % of total students) of Kiribati in 1985 to that in 1996?
Provide a succinct answer. 1. What is the ratio of the Female students (as % of total students) in Bahamas in 1985 to that in 1997?
Offer a very short reply. 0.99. What is the ratio of the Female students (as % of total students) of Ecuador in 1985 to that in 1997?
Your response must be concise. 1. What is the ratio of the Female students (as % of total students) in Ireland in 1985 to that in 1997?
Give a very brief answer. 1. What is the ratio of the Female students (as % of total students) of Kiribati in 1985 to that in 1997?
Ensure brevity in your answer.  1.01. What is the ratio of the Female students (as % of total students) of Ecuador in 1985 to that in 1998?
Ensure brevity in your answer.  1. What is the ratio of the Female students (as % of total students) in Kiribati in 1985 to that in 1998?
Offer a terse response. 1.01. What is the ratio of the Female students (as % of total students) of Kiribati in 1986 to that in 1993?
Provide a short and direct response. 1. What is the ratio of the Female students (as % of total students) in Bahamas in 1986 to that in 1996?
Your answer should be very brief. 0.98. What is the ratio of the Female students (as % of total students) of Ecuador in 1986 to that in 1996?
Give a very brief answer. 1. What is the ratio of the Female students (as % of total students) in Kiribati in 1986 to that in 1997?
Ensure brevity in your answer.  1.01. What is the ratio of the Female students (as % of total students) of Bahamas in 1986 to that in 1998?
Offer a very short reply. 1. What is the ratio of the Female students (as % of total students) of Ireland in 1986 to that in 1998?
Your answer should be compact. 1.01. What is the ratio of the Female students (as % of total students) in Kiribati in 1986 to that in 1998?
Offer a terse response. 1.01. What is the ratio of the Female students (as % of total students) in Bahamas in 1993 to that in 1995?
Your answer should be very brief. 1.01. What is the ratio of the Female students (as % of total students) in Ecuador in 1993 to that in 1995?
Keep it short and to the point. 1. What is the ratio of the Female students (as % of total students) of Bahamas in 1993 to that in 1996?
Provide a short and direct response. 0.99. What is the ratio of the Female students (as % of total students) in Ireland in 1993 to that in 1996?
Ensure brevity in your answer.  1. What is the ratio of the Female students (as % of total students) in Bahamas in 1993 to that in 1997?
Your answer should be very brief. 1. What is the ratio of the Female students (as % of total students) in Ecuador in 1993 to that in 1997?
Provide a succinct answer. 1. What is the ratio of the Female students (as % of total students) of Kiribati in 1993 to that in 1997?
Provide a short and direct response. 1.01. What is the ratio of the Female students (as % of total students) in Bahamas in 1993 to that in 1998?
Ensure brevity in your answer.  1.01. What is the ratio of the Female students (as % of total students) of Bahamas in 1995 to that in 1996?
Offer a very short reply. 0.98. What is the ratio of the Female students (as % of total students) of Ecuador in 1995 to that in 1996?
Make the answer very short. 1. What is the ratio of the Female students (as % of total students) of Ireland in 1995 to that in 1996?
Your answer should be compact. 1. What is the ratio of the Female students (as % of total students) of Kiribati in 1995 to that in 1996?
Provide a short and direct response. 1. What is the ratio of the Female students (as % of total students) of Bahamas in 1995 to that in 1997?
Your answer should be very brief. 1. What is the ratio of the Female students (as % of total students) of Ecuador in 1995 to that in 1997?
Offer a terse response. 1. What is the ratio of the Female students (as % of total students) in Ireland in 1995 to that in 1997?
Give a very brief answer. 1. What is the ratio of the Female students (as % of total students) in Kiribati in 1995 to that in 1997?
Your response must be concise. 1.01. What is the ratio of the Female students (as % of total students) in Bahamas in 1995 to that in 1998?
Offer a very short reply. 1. What is the ratio of the Female students (as % of total students) of Ecuador in 1995 to that in 1998?
Keep it short and to the point. 1. What is the ratio of the Female students (as % of total students) in Bahamas in 1996 to that in 1997?
Give a very brief answer. 1.01. What is the ratio of the Female students (as % of total students) in Ireland in 1996 to that in 1997?
Your answer should be very brief. 1. What is the ratio of the Female students (as % of total students) of Kiribati in 1996 to that in 1997?
Your answer should be very brief. 1.01. What is the ratio of the Female students (as % of total students) of Bahamas in 1996 to that in 1998?
Offer a terse response. 1.02. What is the ratio of the Female students (as % of total students) in Ireland in 1996 to that in 1998?
Your response must be concise. 1. What is the ratio of the Female students (as % of total students) in Kiribati in 1996 to that in 1998?
Offer a very short reply. 1.01. What is the difference between the highest and the second highest Female students (as % of total students) of Bahamas?
Your response must be concise. 0.5. What is the difference between the highest and the second highest Female students (as % of total students) in Ecuador?
Ensure brevity in your answer.  0.06. What is the difference between the highest and the second highest Female students (as % of total students) of Ireland?
Your answer should be very brief. 0.06. What is the difference between the highest and the second highest Female students (as % of total students) of Kiribati?
Your answer should be compact. 0.04. What is the difference between the highest and the lowest Female students (as % of total students) of Bahamas?
Provide a short and direct response. 0.98. What is the difference between the highest and the lowest Female students (as % of total students) in Ecuador?
Your answer should be compact. 0.17. What is the difference between the highest and the lowest Female students (as % of total students) in Ireland?
Give a very brief answer. 0.29. What is the difference between the highest and the lowest Female students (as % of total students) of Kiribati?
Provide a succinct answer. 0.48. 